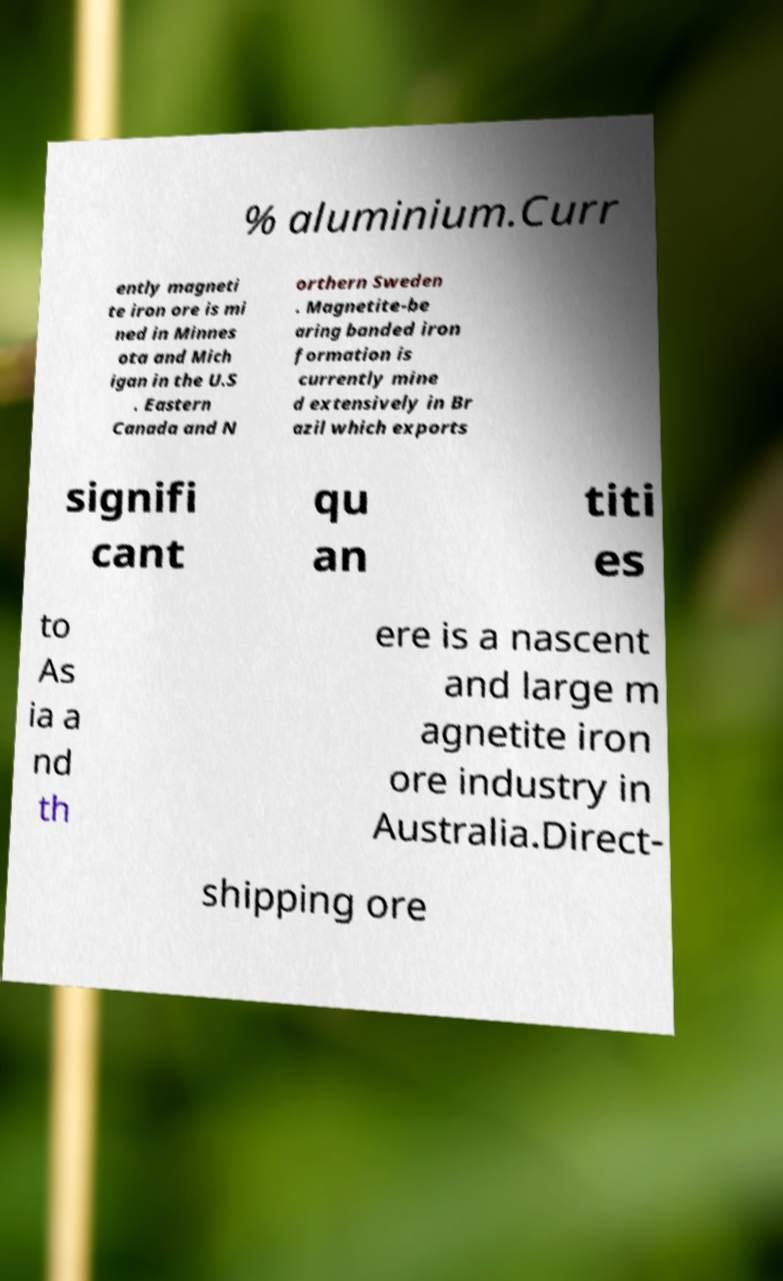There's text embedded in this image that I need extracted. Can you transcribe it verbatim? % aluminium.Curr ently magneti te iron ore is mi ned in Minnes ota and Mich igan in the U.S . Eastern Canada and N orthern Sweden . Magnetite-be aring banded iron formation is currently mine d extensively in Br azil which exports signifi cant qu an titi es to As ia a nd th ere is a nascent and large m agnetite iron ore industry in Australia.Direct- shipping ore 